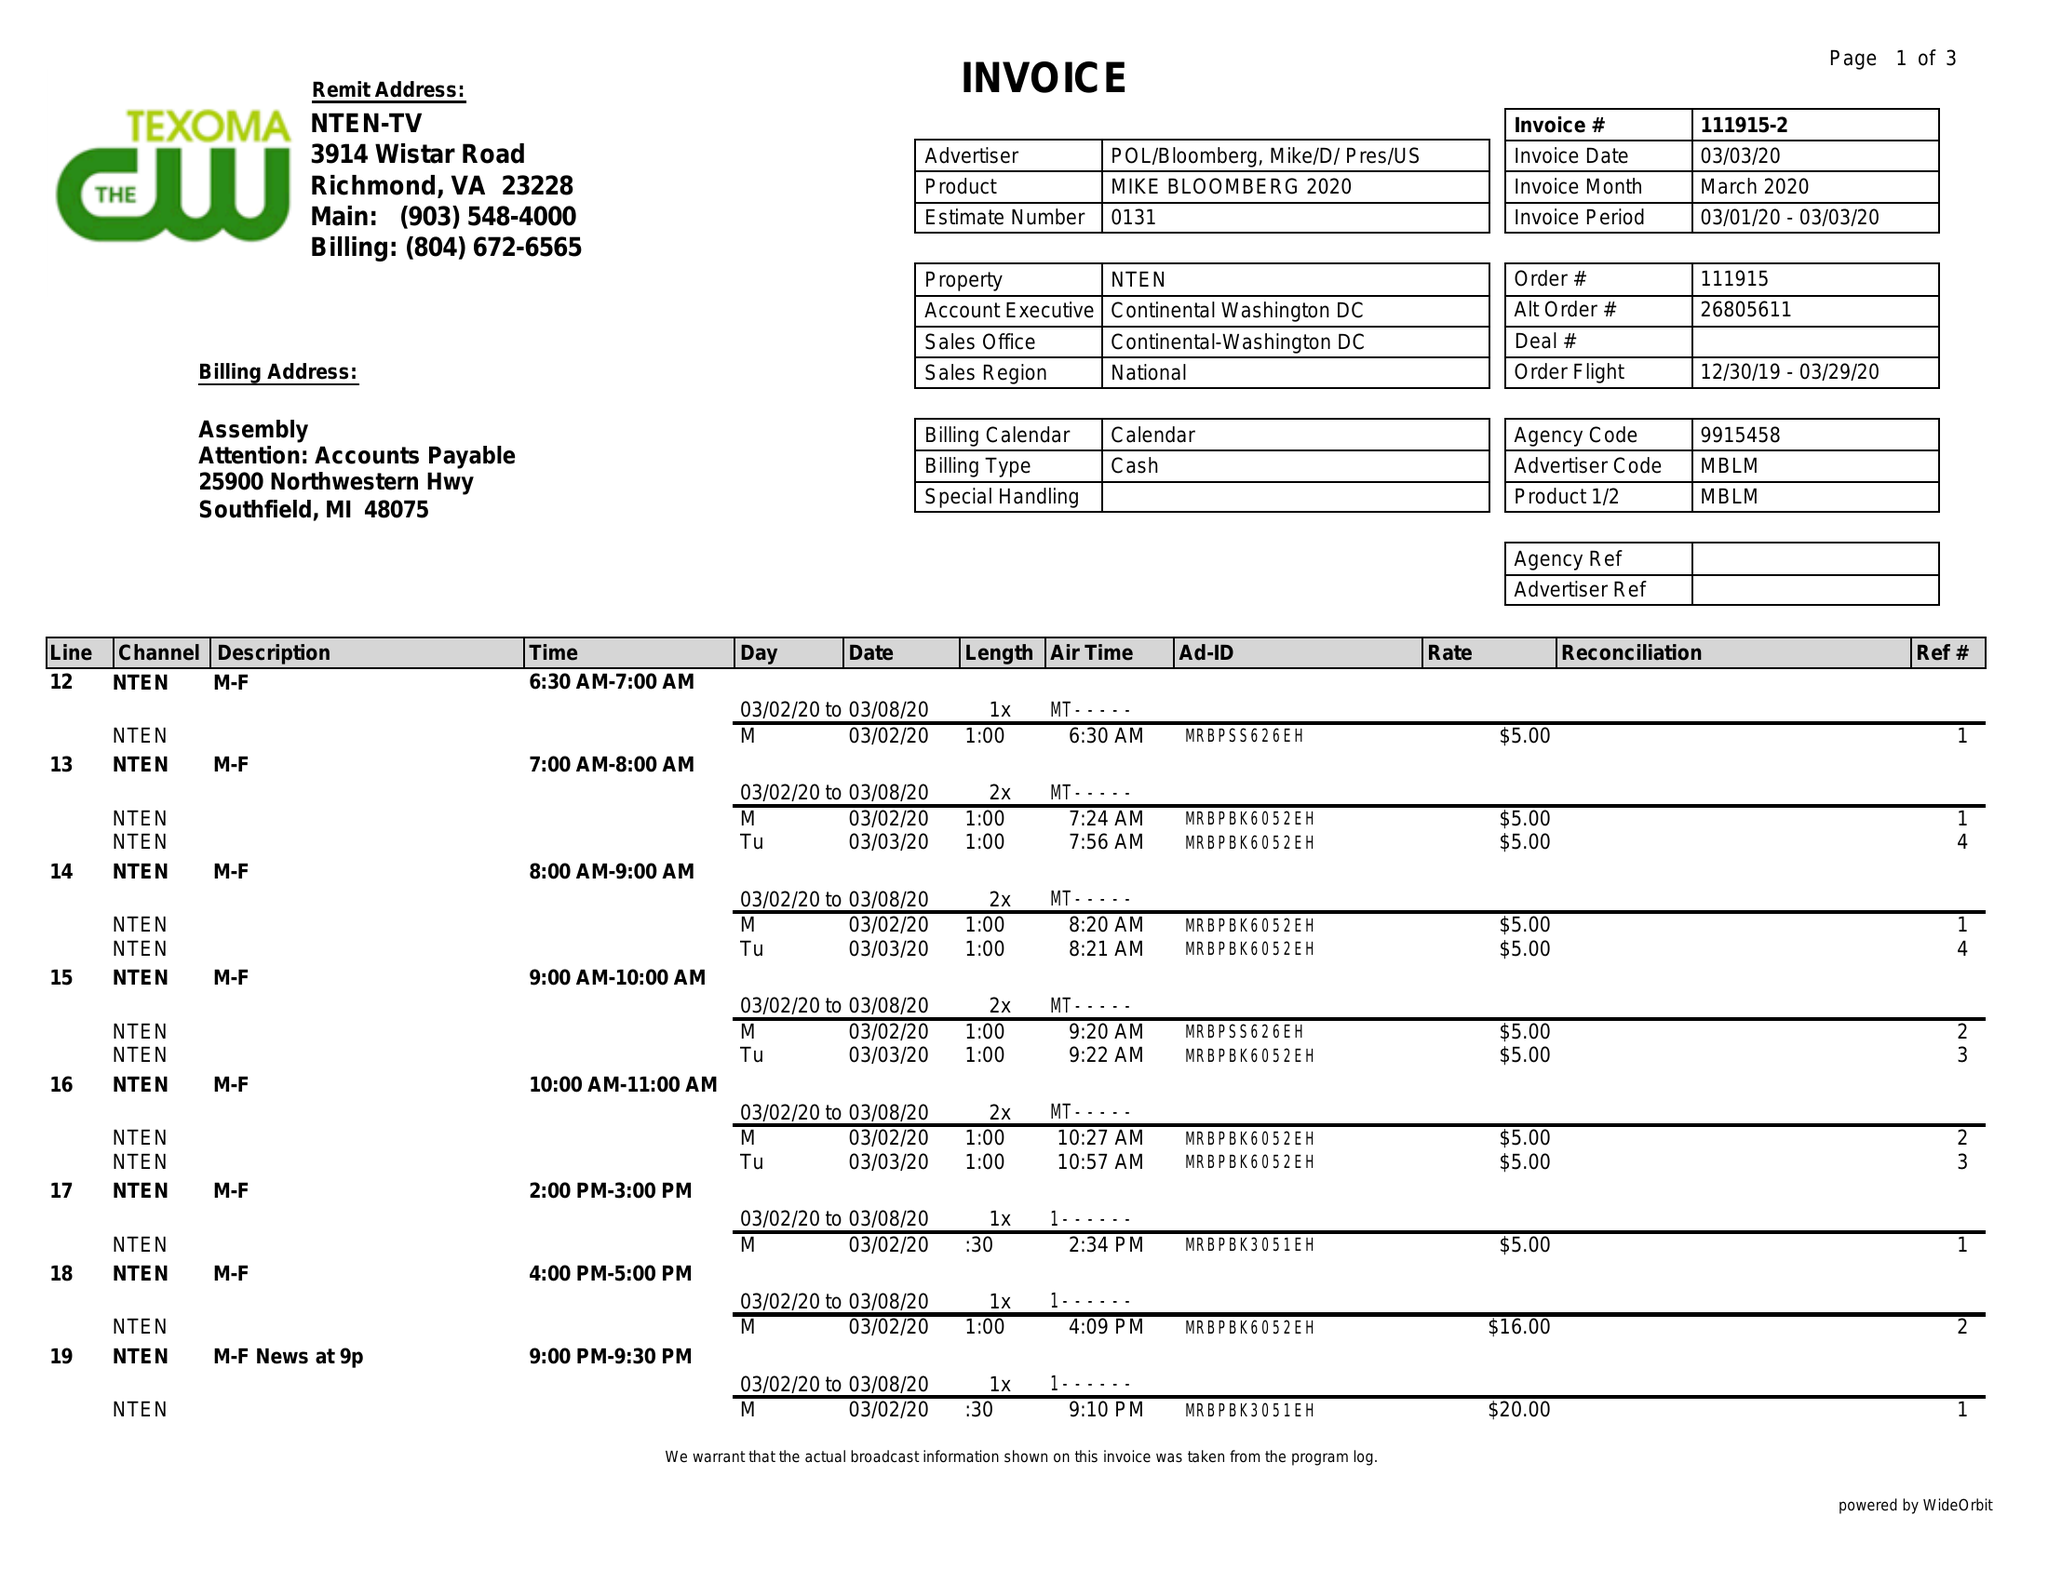What is the value for the contract_num?
Answer the question using a single word or phrase. 111915 